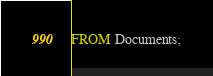<code> <loc_0><loc_0><loc_500><loc_500><_SQL_>FROM Documents;
</code> 